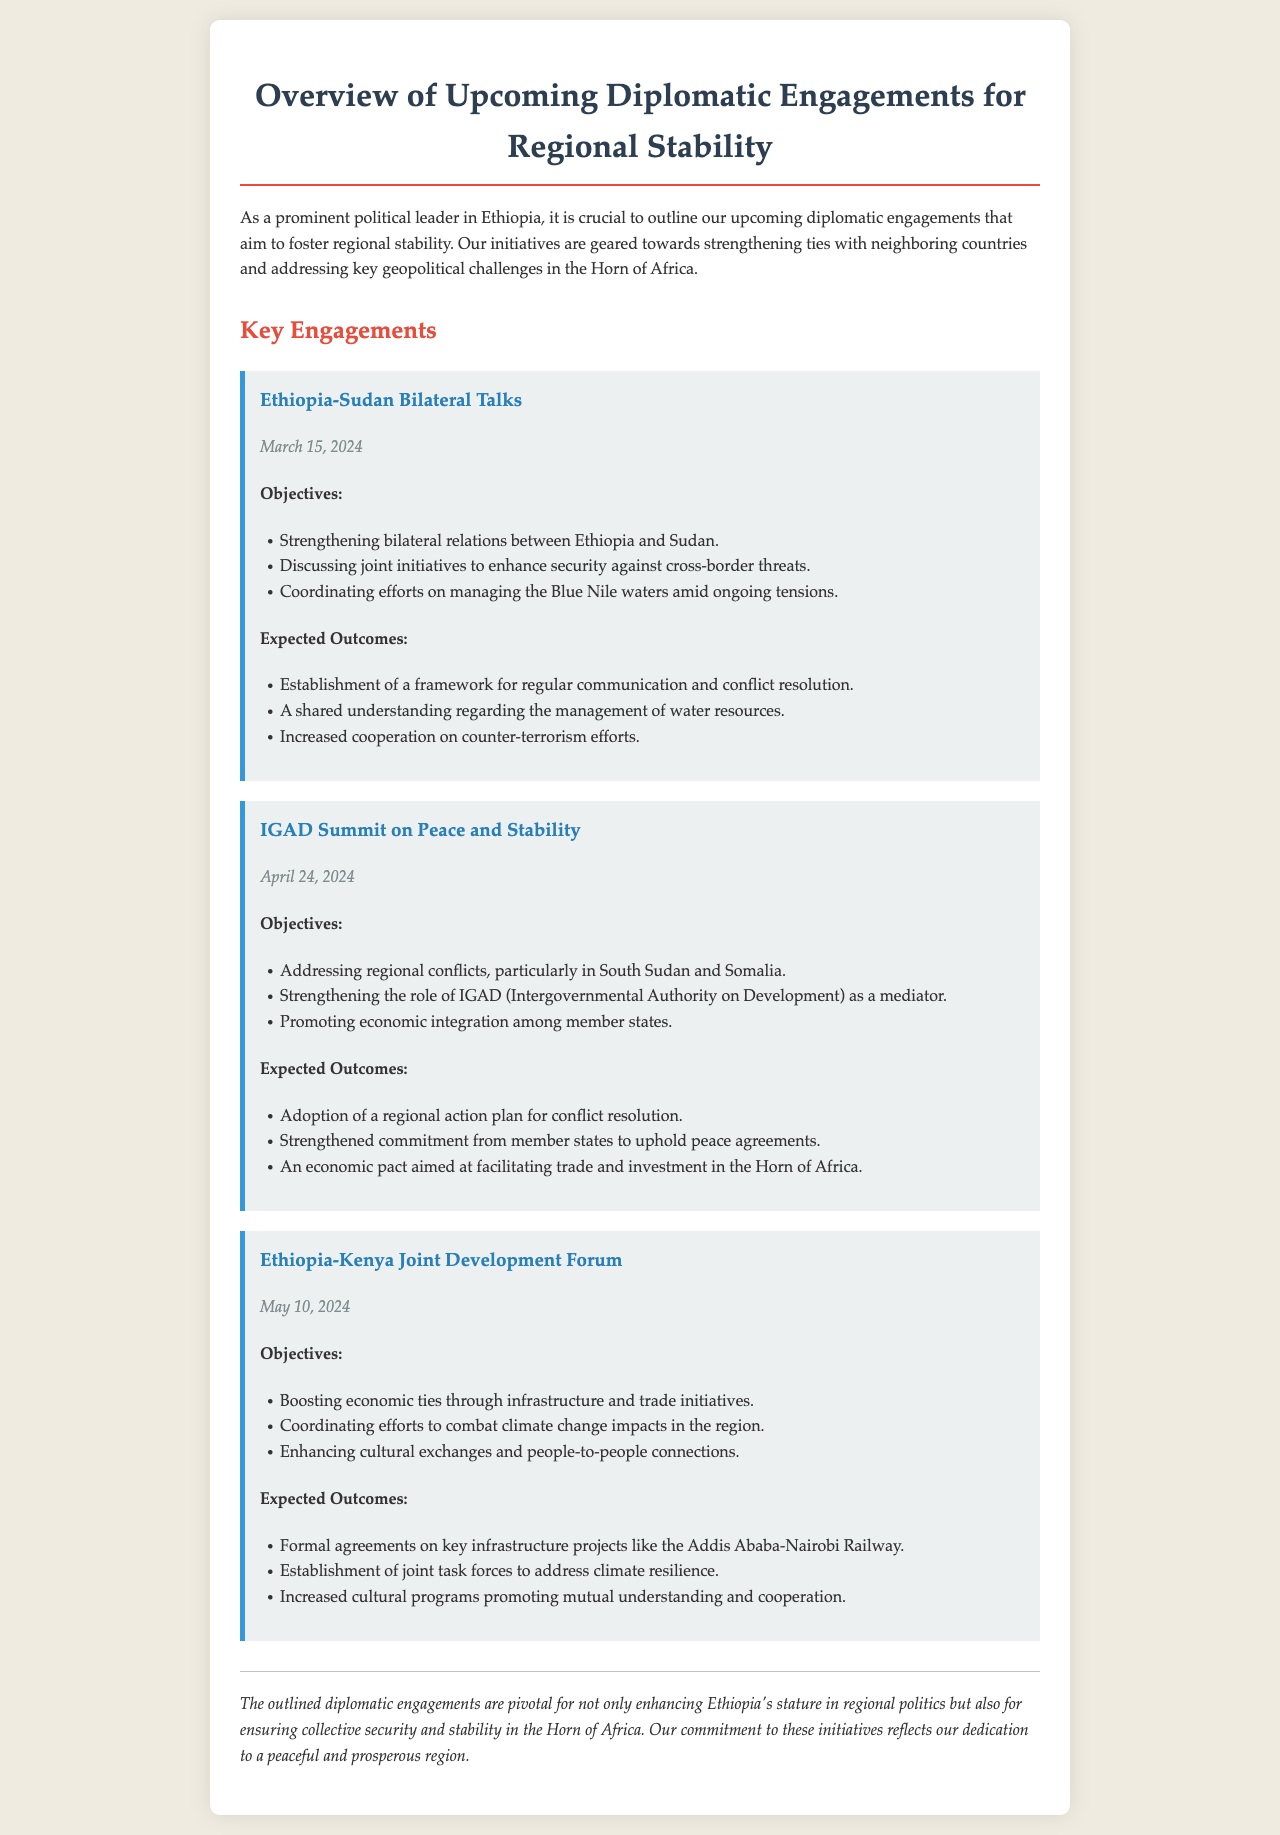What is the date of the Ethiopia-Sudan Bilateral Talks? The document specifies the date of the Ethiopia-Sudan Bilateral Talks as March 15, 2024.
Answer: March 15, 2024 What are the key objectives of the IGAD Summit? The document lists the objectives of the IGAD Summit as addressing regional conflicts, strengthening IGAD's role, and promoting economic integration.
Answer: Addressing regional conflicts, strengthening IGAD's role, promoting economic integration What is one expected outcome of the Ethiopia-Kenya Joint Development Forum? The document mentions formal agreements on key infrastructure projects as one of the expected outcomes of the Ethiopia-Kenya Joint Development Forum.
Answer: Formal agreements on key infrastructure projects How many key engagements are outlined in the document? The document outlines three key engagements focused on regional stability.
Answer: Three What role does IGAD play in the regional stability efforts? According to the document, IGAD acts as a mediator in conflicts and is involved in strengthening commitments to peace agreements.
Answer: Mediator What is the primary focus of the Ethiopia-Sudan Bilateral Talks? The document highlights the primary focus of the Ethiopia-Sudan Bilateral Talks as strengthening bilateral relations and security against cross-border threats.
Answer: Strengthening bilateral relations and security against cross-border threats What is the expected outcome regarding economic integration at the IGAD Summit? The document notes that a regional action plan for conflict resolution and an economic pact for trade and investment are expected outcomes.
Answer: An economic pact for trade and investment What is the overarching theme of the document? The document emphasizes that the overarching theme revolves around upcoming diplomatic engagements for regional stability in the Horn of Africa.
Answer: Upcoming diplomatic engagements for regional stability 